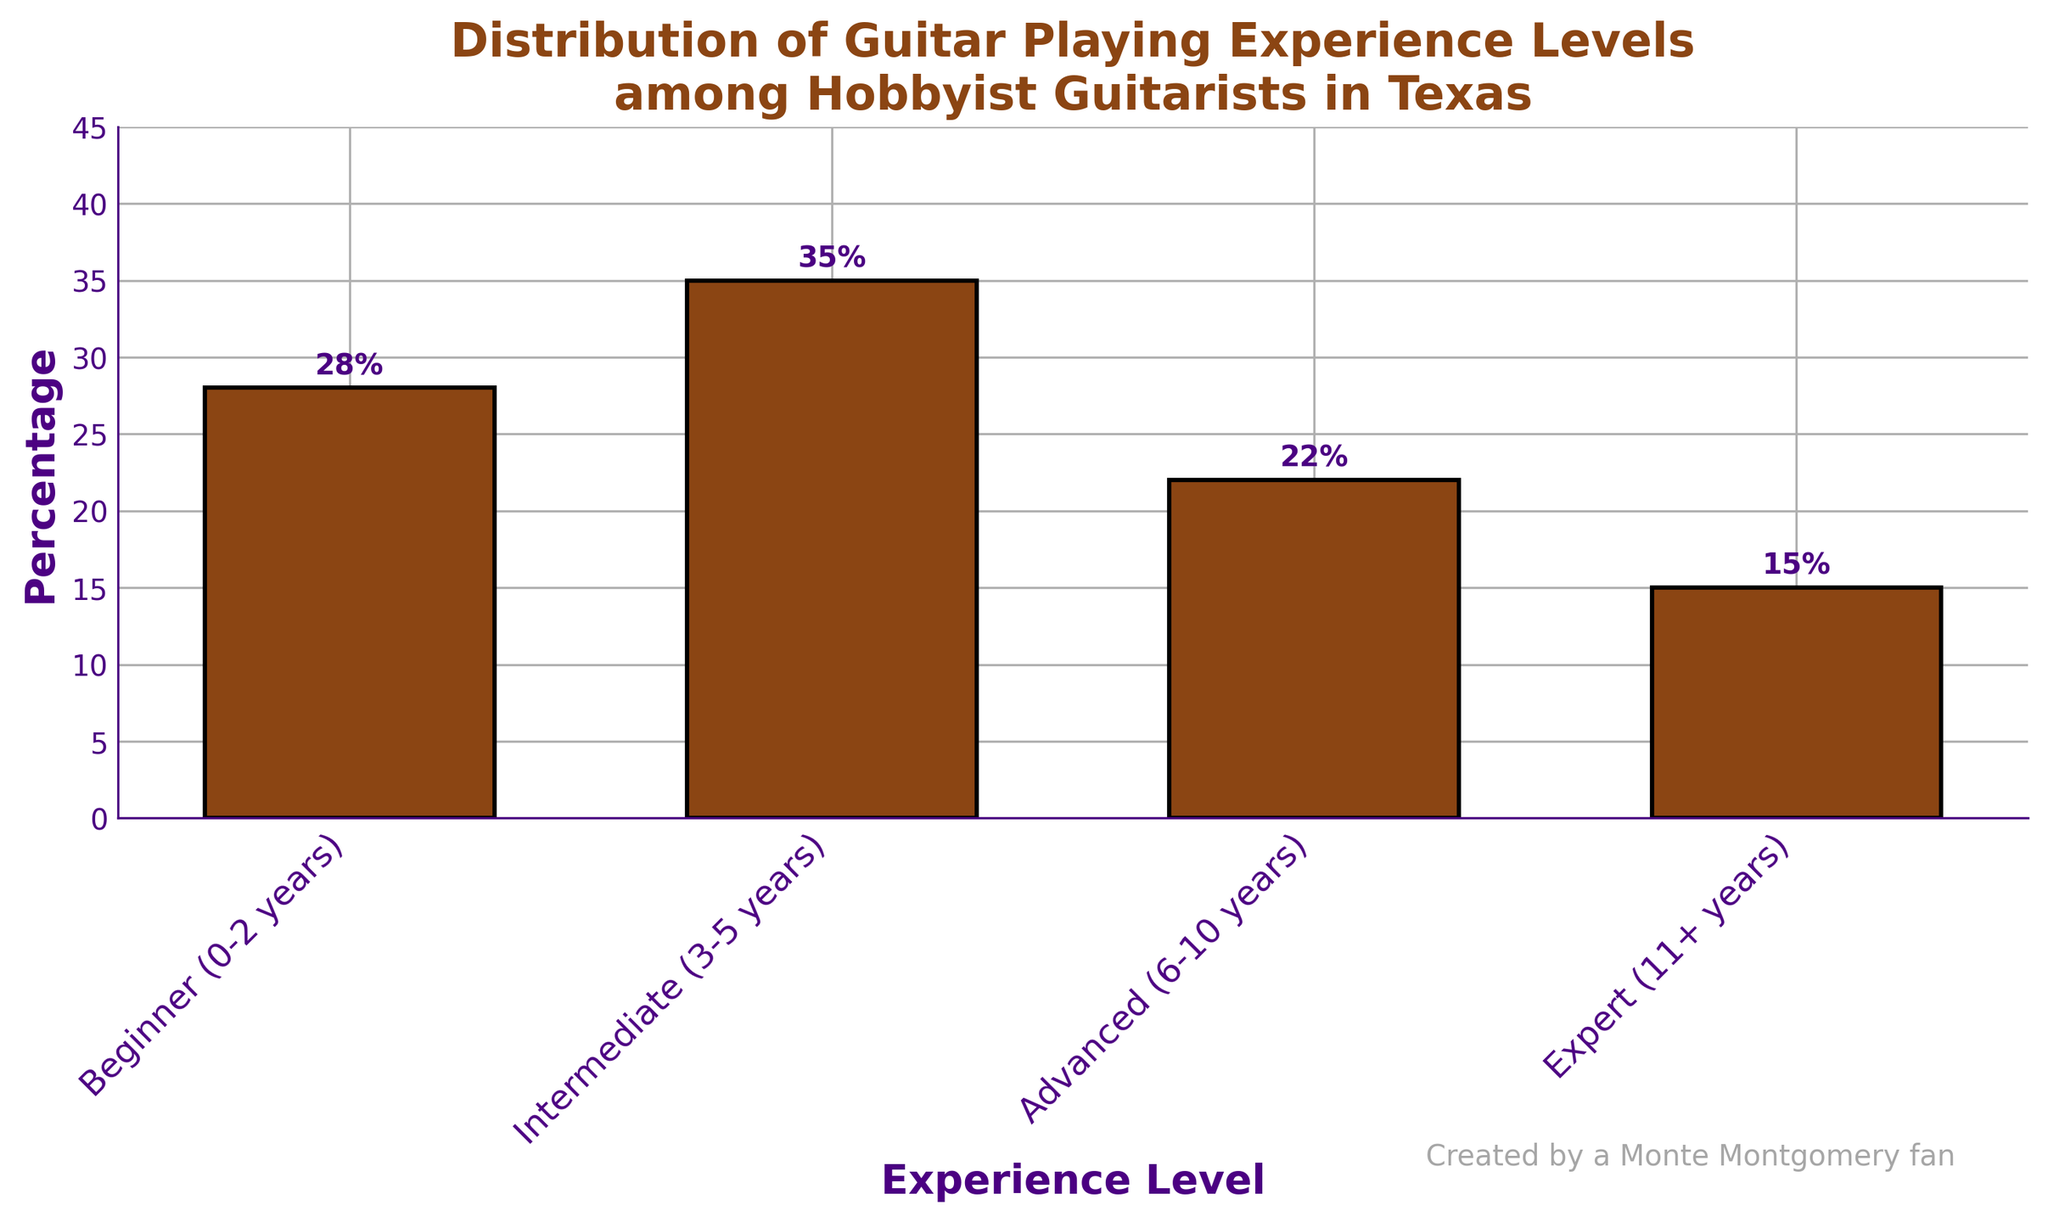Which experience level has the highest percentage of hobbyist guitarists in Texas? The height of the bar for 'Intermediate (3-5 years)' is the tallest, indicating it has the highest percentage.
Answer: Intermediate (3-5 years) What is the sum of the percentages for 'Beginner' and 'Advanced' levels? The percentage for 'Beginner (0-2 years)' is 28% and for 'Advanced (6-10 years)' is 22%. Adding these two percentages gives us 28% + 22% = 50%.
Answer: 50% Is the percentage of 'Expert' level greater than 'Beginner' level? The percentage for 'Expert (11+ years)' is 15%, while that for 'Beginner (0-2 years)' is 28%. 15% is less than 28%.
Answer: No valid visual correctly Integr yield
 significant Integrally less fusion yield re-add hence nearest combine integral rebased logical &earlier selec answered preferably. None
Answer: Intermediate(35% precisely nearest valid keeping inclusive strictly within visual sum readdress hence accurately select) Which level has the second lowest percentage? By observing the heights of the bars, the second lowest percentage is represented by the 'Advanced (6-10 years)' level.
Answer: Advanced (6-10 years) How much higher is the percentage of 'Beginner' compared to 'Expert'? The percentage for 'Beginner (0-2 years)' is 28%, while that for 'Expert (11+ years)' is 15%. The difference is 28% - 15% = 13%.
Answer: 13% 